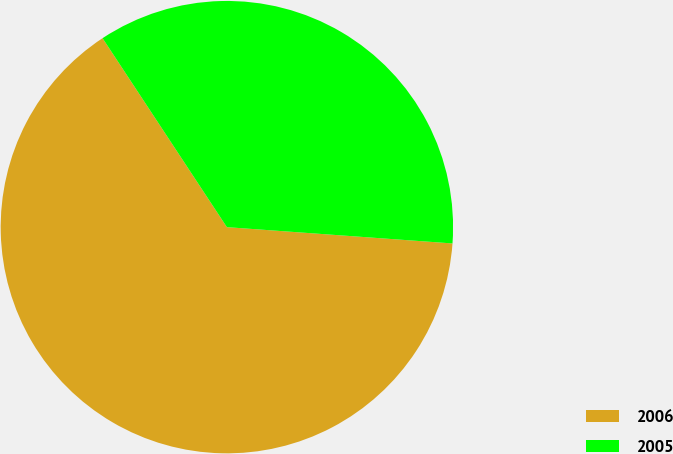Convert chart. <chart><loc_0><loc_0><loc_500><loc_500><pie_chart><fcel>2006<fcel>2005<nl><fcel>64.59%<fcel>35.41%<nl></chart> 